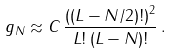Convert formula to latex. <formula><loc_0><loc_0><loc_500><loc_500>g _ { N } \approx C \, \frac { ( \left ( L - N / 2 ) ! \right ) ^ { 2 } } { L ! \, ( L - N ) ! } \, .</formula> 